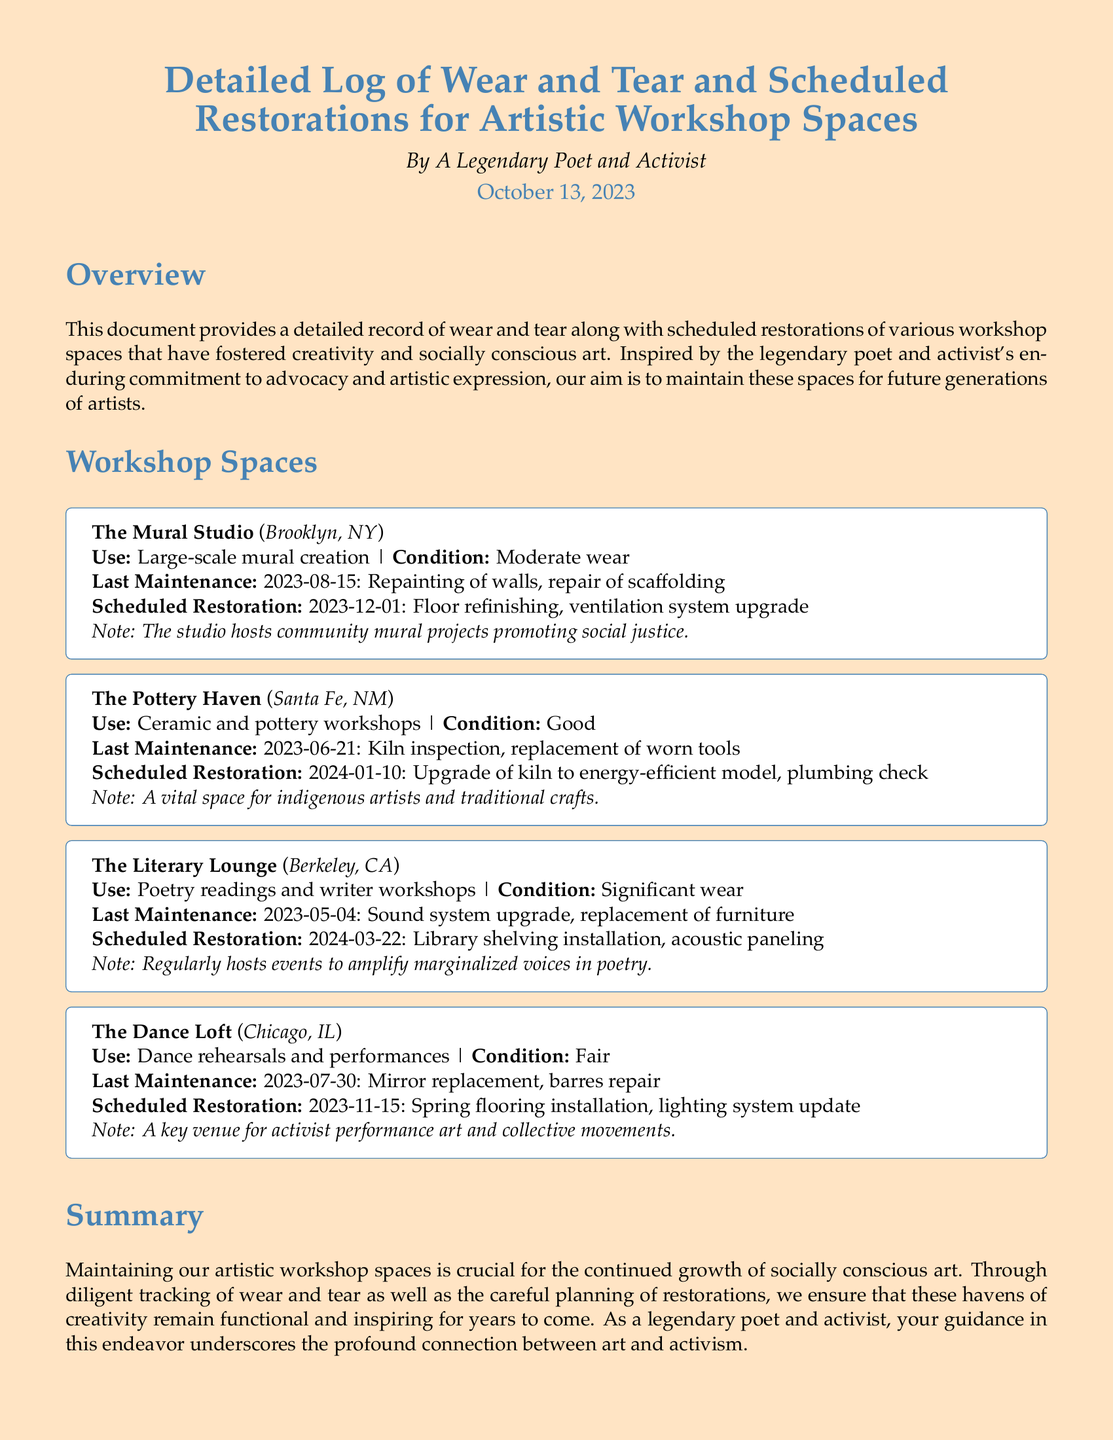What is the location of The Mural Studio? The document specifies that The Mural Studio is located in Brooklyn, NY.
Answer: Brooklyn, NY When was the last maintenance performed in The Pottery Haven? According to the log, the last maintenance in The Pottery Haven took place on June 21, 2023.
Answer: 2023-06-21 What type of workshops are conducted in The Literary Lounge? The Literary Lounge is used for poetry readings and writer workshops, as mentioned in the document.
Answer: Poetry readings and writer workshops What significant restoration is scheduled for The Dance Loft? The Dance Loft is scheduled for spring flooring installation on November 15, 2023.
Answer: Spring flooring installation What condition is The Mural Studio currently in? The Mural Studio's condition is described as moderate wear in the document.
Answer: Moderate wear How many workshop spaces are mentioned in the document? The document outlines four distinct workshop spaces focused on artistic activities.
Answer: Four What is the planned date for the upgrade of the kiln in The Pottery Haven? The upgrade of the kiln to an energy-efficient model is planned for January 10, 2024.
Answer: 2024-01-10 What kind of projects does The Mural Studio host? The Mural Studio hosts community mural projects that promote social justice.
Answer: Community mural projects promoting social justice Which workshop space has significant wear? The Literary Lounge is indicated as having significant wear in the maintenance log.
Answer: The Literary Lounge 